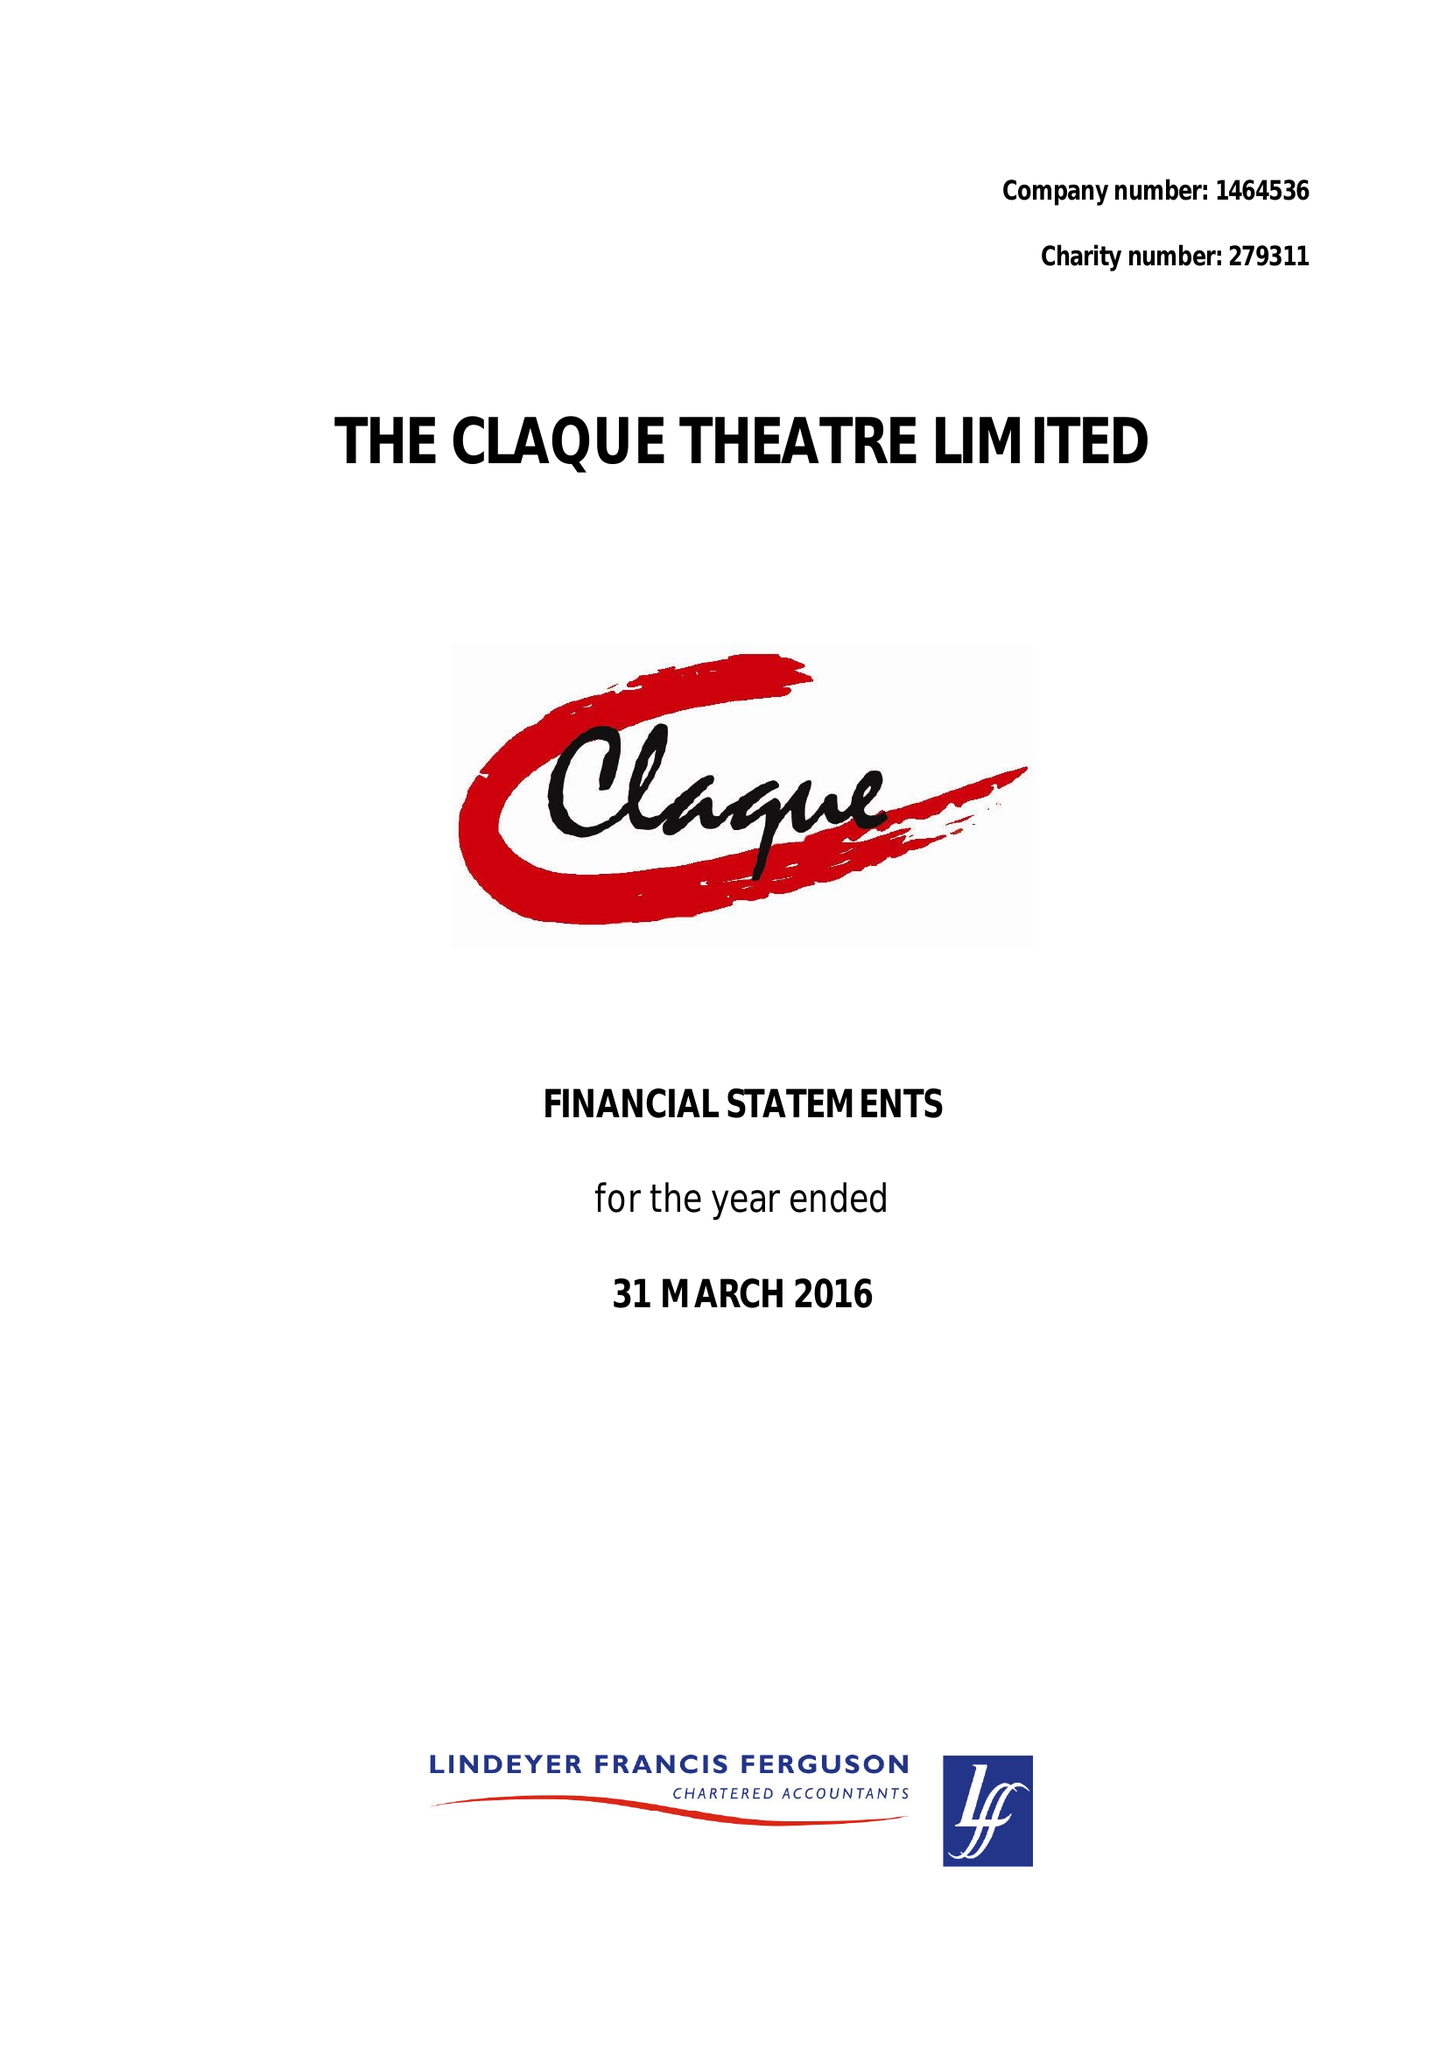What is the value for the report_date?
Answer the question using a single word or phrase. 2016-03-31 